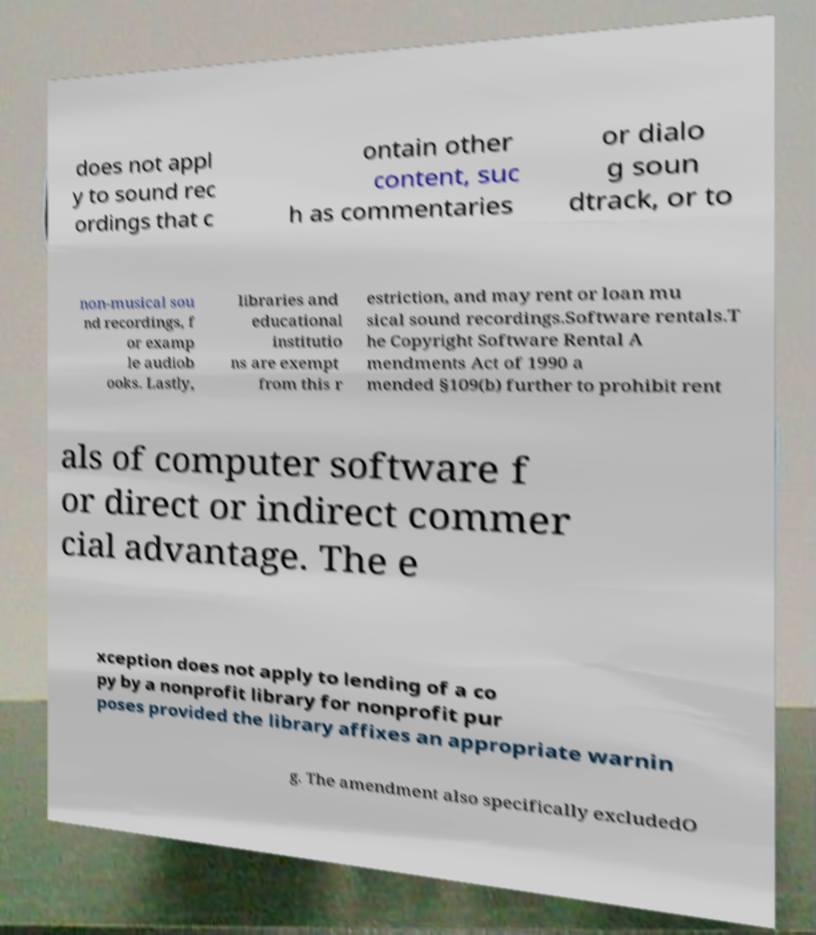Please read and relay the text visible in this image. What does it say? does not appl y to sound rec ordings that c ontain other content, suc h as commentaries or dialo g soun dtrack, or to non-musical sou nd recordings, f or examp le audiob ooks. Lastly, libraries and educational institutio ns are exempt from this r estriction, and may rent or loan mu sical sound recordings.Software rentals.T he Copyright Software Rental A mendments Act of 1990 a mended §109(b) further to prohibit rent als of computer software f or direct or indirect commer cial advantage. The e xception does not apply to lending of a co py by a nonprofit library for nonprofit pur poses provided the library affixes an appropriate warnin g. The amendment also specifically excludedO 